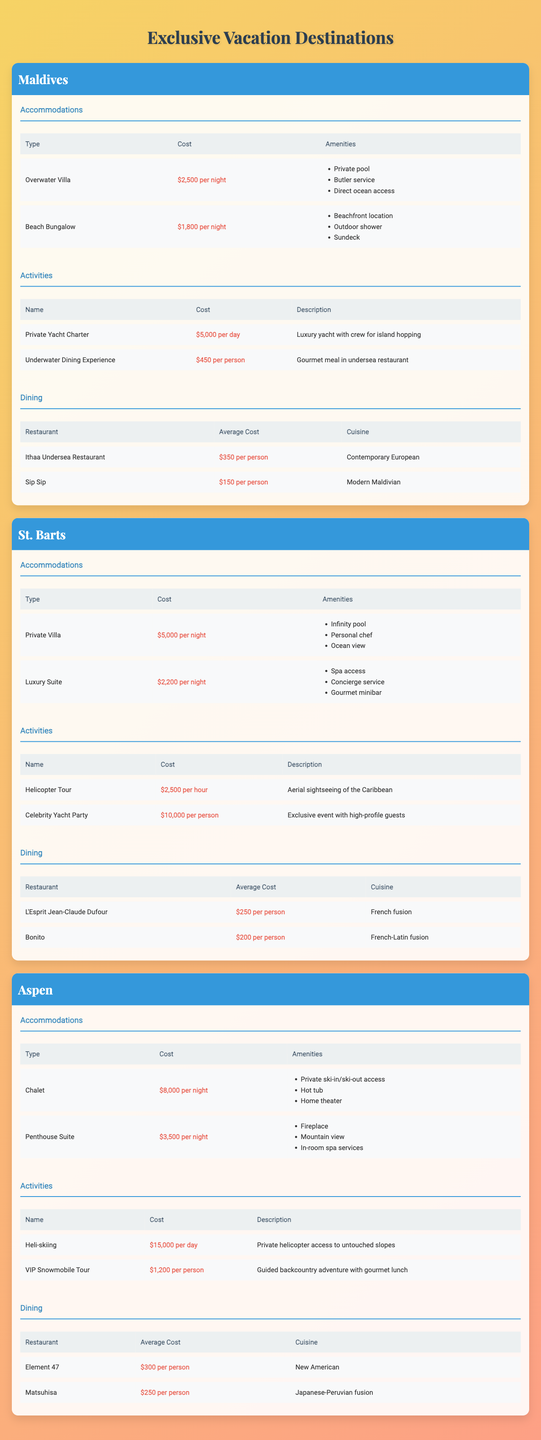What type of accommodation is available in the Maldives? The table lists two types of accommodations for the Maldives: "Overwater Villa" and "Beach Bungalow."
Answer: Overwater Villa, Beach Bungalow What is the cost of a Private Villa in St. Barts? According to the table, the cost of a Private Villa in St. Barts is $5,000 per night.
Answer: $5,000 per night How many dining options are available in Aspen? The table presents two dining options in Aspen: "Element 47" and "Matsuhisa."
Answer: 2 Which destination has the highest accommodation cost? By comparing the costs, Aspen's Chalet at $8,000 per night is higher than the other accommodations listed.
Answer: Aspen What is the average cost of dining per person in the Maldives? The average cost of dining in the Maldives can be calculated: (Ithaa Undersea Restaurant: $350 + Sip Sip: $150) / 2 = $250.
Answer: $250 In which destination is a helicopter tour available, and what is its cost? The table indicates that a helicopter tour is available in St. Barts for $2,500 per hour.
Answer: St. Barts, $2,500 per hour Is there an underwater dining experience in Aspen? The table does not list any underwater dining experience for Aspen, while the Maldives has this option.
Answer: No What is the total accommodation cost for one night in St. Barts if you choose both options? The cost of both accommodations in St. Barts is: $5,000 (Private Villa) + $2,200 (Luxury Suite) = $7,200.
Answer: $7,200 Which dining option in St. Barts has the lowest average cost per person? Comparing the average dining costs, "Bonito" at $200 per person is lower than "L'Esprit Jean-Claude Dufour" at $250.
Answer: Bonito What is the total cost of the Private Yacht Charter and the Underwater Dining Experience in the Maldives for one day? The combined cost is $5,000 (Private Yacht Charter) + ($450 per person for two people, total $900) = $5,900.
Answer: $5,900 What amenities are included in the Beach Bungalow in the Maldives? The Beach Bungalow offers amenities such as beachfront location, outdoor shower, and sundeck according to the table.
Answer: Beachfront location, outdoor shower, sundeck Can you find a dining option in Aspen that costs less than $300? Yes, "Matsuhisa" costs $250 per person, which is below $300.
Answer: Yes If someone wanted to experience both heli-skiing and dining in Aspen, what would be the total cost for one person? The total cost for heli-skiing ($15,000) and dining at Element 47 ($300) would be $15,300.
Answer: $15,300 